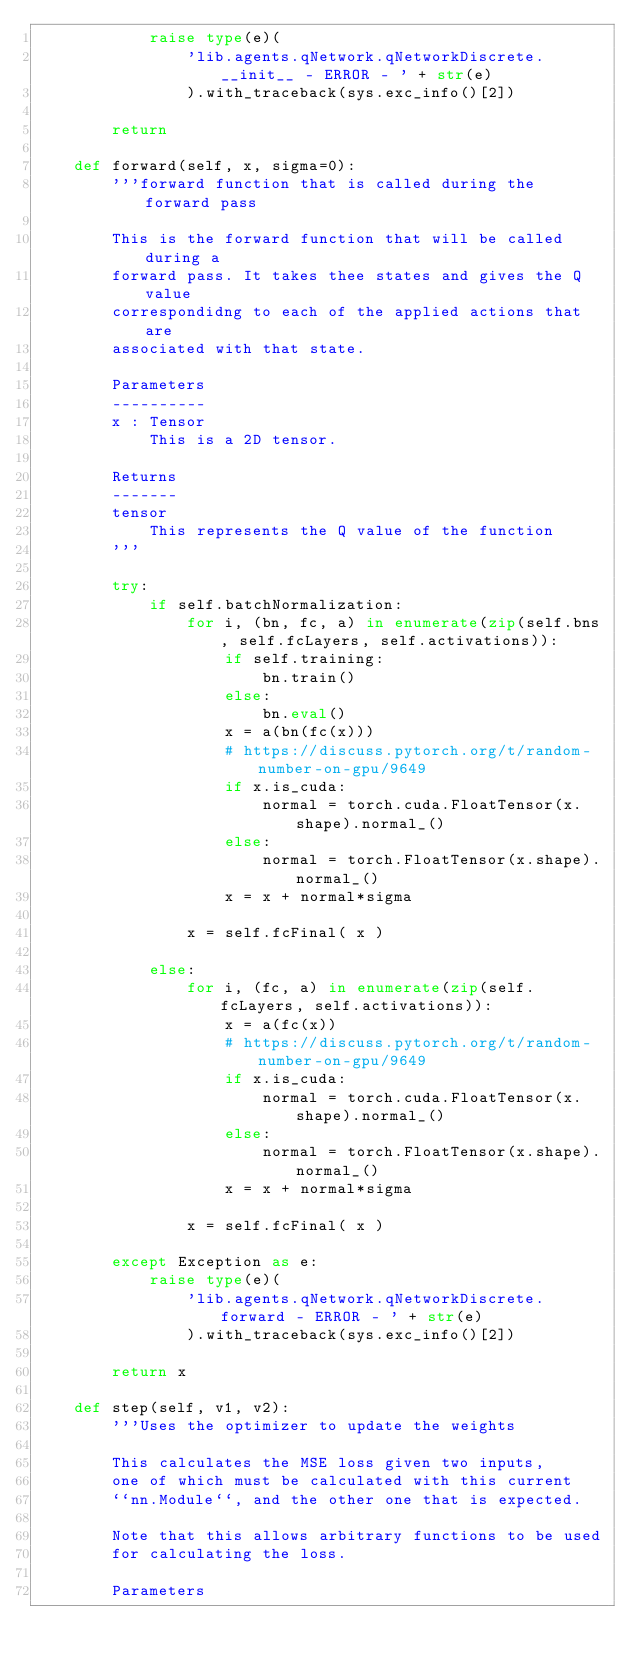Convert code to text. <code><loc_0><loc_0><loc_500><loc_500><_Python_>            raise type(e)( 
                'lib.agents.qNetwork.qNetworkDiscrete.__init__ - ERROR - ' + str(e) 
                ).with_traceback(sys.exc_info()[2])

        return

    def forward(self, x, sigma=0):
        '''forward function that is called during the forward pass
        
        This is the forward function that will be called during a 
        forward pass. It takes thee states and gives the Q value 
        correspondidng to each of the applied actions that are 
        associated with that state. 
        
        Parameters
        ----------
        x : Tensor
            This is a 2D tensor. 
        
        Returns
        -------
        tensor
            This represents the Q value of the function
        '''

        try:
            if self.batchNormalization:
                for i, (bn, fc, a) in enumerate(zip(self.bns, self.fcLayers, self.activations)):
                    if self.training:
                        bn.train()
                    else:
                        bn.eval()
                    x = a(bn(fc(x)))
                    # https://discuss.pytorch.org/t/random-number-on-gpu/9649
                    if x.is_cuda:
                        normal = torch.cuda.FloatTensor(x.shape).normal_()
                    else:
                        normal = torch.FloatTensor(x.shape).normal_()
                    x = x + normal*sigma

                x = self.fcFinal( x )

            else:
                for i, (fc, a) in enumerate(zip(self.fcLayers, self.activations)):
                    x = a(fc(x))
                    # https://discuss.pytorch.org/t/random-number-on-gpu/9649
                    if x.is_cuda:
                        normal = torch.cuda.FloatTensor(x.shape).normal_()
                    else:
                        normal = torch.FloatTensor(x.shape).normal_()
                    x = x + normal*sigma

                x = self.fcFinal( x )

        except Exception as e:
            raise type(e)( 
                'lib.agents.qNetwork.qNetworkDiscrete.forward - ERROR - ' + str(e) 
                ).with_traceback(sys.exc_info()[2])

        return x

    def step(self, v1, v2):
        '''Uses the optimizer to update the weights
        
        This calculates the MSE loss given two inputs,
        one of which must be calculated with this current
        ``nn.Module``, and the other one that is expected.
        
        Note that this allows arbitrary functions to be used
        for calculating the loss.
        
        Parameters</code> 